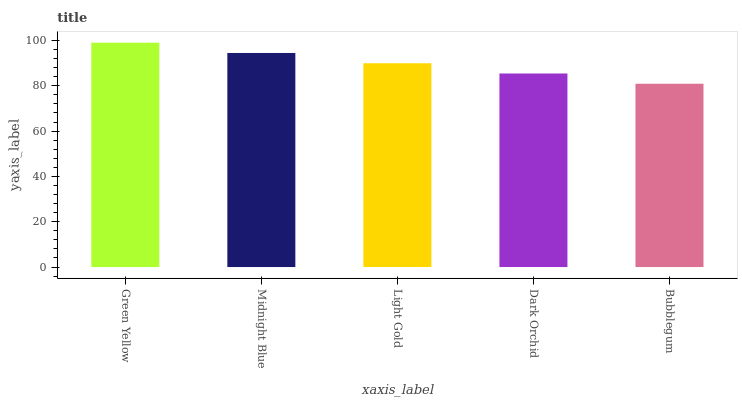Is Midnight Blue the minimum?
Answer yes or no. No. Is Midnight Blue the maximum?
Answer yes or no. No. Is Green Yellow greater than Midnight Blue?
Answer yes or no. Yes. Is Midnight Blue less than Green Yellow?
Answer yes or no. Yes. Is Midnight Blue greater than Green Yellow?
Answer yes or no. No. Is Green Yellow less than Midnight Blue?
Answer yes or no. No. Is Light Gold the high median?
Answer yes or no. Yes. Is Light Gold the low median?
Answer yes or no. Yes. Is Green Yellow the high median?
Answer yes or no. No. Is Green Yellow the low median?
Answer yes or no. No. 